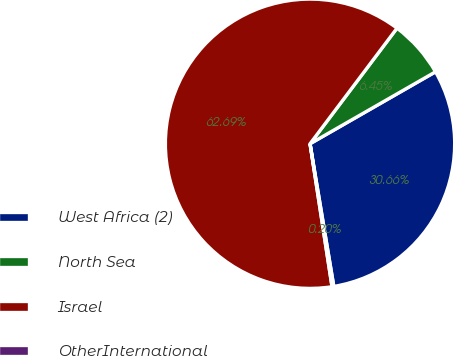Convert chart to OTSL. <chart><loc_0><loc_0><loc_500><loc_500><pie_chart><fcel>West Africa (2)<fcel>North Sea<fcel>Israel<fcel>OtherInternational<nl><fcel>30.66%<fcel>6.45%<fcel>62.7%<fcel>0.2%<nl></chart> 